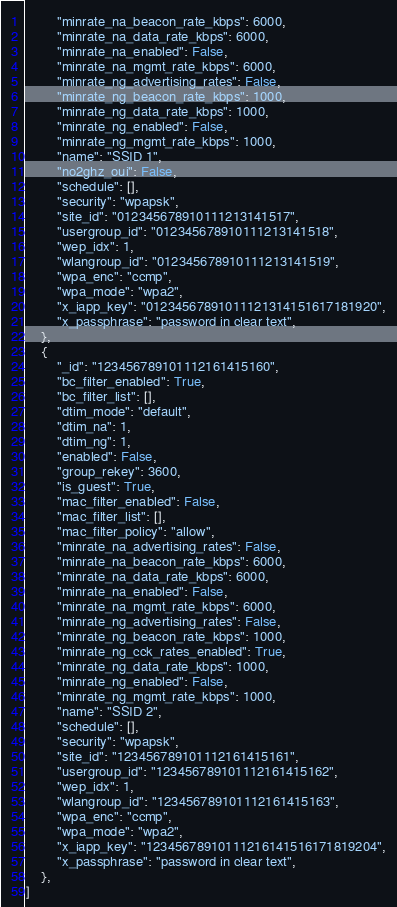<code> <loc_0><loc_0><loc_500><loc_500><_Python_>        "minrate_na_beacon_rate_kbps": 6000,
        "minrate_na_data_rate_kbps": 6000,
        "minrate_na_enabled": False,
        "minrate_na_mgmt_rate_kbps": 6000,
        "minrate_ng_advertising_rates": False,
        "minrate_ng_beacon_rate_kbps": 1000,
        "minrate_ng_data_rate_kbps": 1000,
        "minrate_ng_enabled": False,
        "minrate_ng_mgmt_rate_kbps": 1000,
        "name": "SSID 1",
        "no2ghz_oui": False,
        "schedule": [],
        "security": "wpapsk",
        "site_id": "012345678910111213141517",
        "usergroup_id": "012345678910111213141518",
        "wep_idx": 1,
        "wlangroup_id": "012345678910111213141519",
        "wpa_enc": "ccmp",
        "wpa_mode": "wpa2",
        "x_iapp_key": "01234567891011121314151617181920",
        "x_passphrase": "password in clear text",
    },
    {
        "_id": "123456789101112161415160",
        "bc_filter_enabled": True,
        "bc_filter_list": [],
        "dtim_mode": "default",
        "dtim_na": 1,
        "dtim_ng": 1,
        "enabled": False,
        "group_rekey": 3600,
        "is_guest": True,
        "mac_filter_enabled": False,
        "mac_filter_list": [],
        "mac_filter_policy": "allow",
        "minrate_na_advertising_rates": False,
        "minrate_na_beacon_rate_kbps": 6000,
        "minrate_na_data_rate_kbps": 6000,
        "minrate_na_enabled": False,
        "minrate_na_mgmt_rate_kbps": 6000,
        "minrate_ng_advertising_rates": False,
        "minrate_ng_beacon_rate_kbps": 1000,
        "minrate_ng_cck_rates_enabled": True,
        "minrate_ng_data_rate_kbps": 1000,
        "minrate_ng_enabled": False,
        "minrate_ng_mgmt_rate_kbps": 1000,
        "name": "SSID 2",
        "schedule": [],
        "security": "wpapsk",
        "site_id": "123456789101112161415161",
        "usergroup_id": "123456789101112161415162",
        "wep_idx": 1,
        "wlangroup_id": "123456789101112161415163",
        "wpa_enc": "ccmp",
        "wpa_mode": "wpa2",
        "x_iapp_key": "12345678910111216141516171819204",
        "x_passphrase": "password in clear text",
    },
]
</code> 